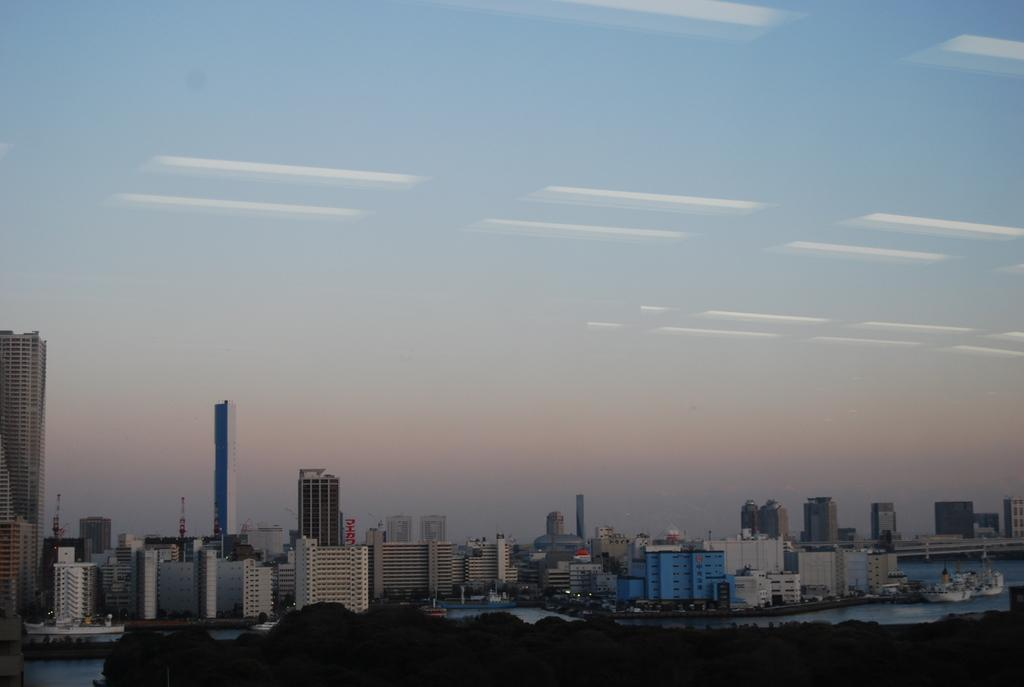What type of structures can be seen in the image? There are buildings in the image, including tower buildings. What can be seen in the background of the image? The sky is visible in the background of the image. How many children are playing with the powder in the image? There is no powder or children present in the image. What type of goose can be seen in the image? There is no goose present in the image. 